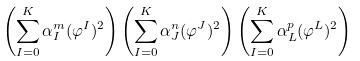<formula> <loc_0><loc_0><loc_500><loc_500>\left ( \sum _ { I = 0 } ^ { K } \alpha _ { I } ^ { m } ( \varphi ^ { I } ) ^ { 2 } \right ) \left ( \sum _ { I = 0 } ^ { K } \alpha _ { J } ^ { n } ( \varphi ^ { J } ) ^ { 2 } \right ) \left ( \sum _ { I = 0 } ^ { K } \alpha _ { L } ^ { p } ( \varphi ^ { L } ) ^ { 2 } \right )</formula> 